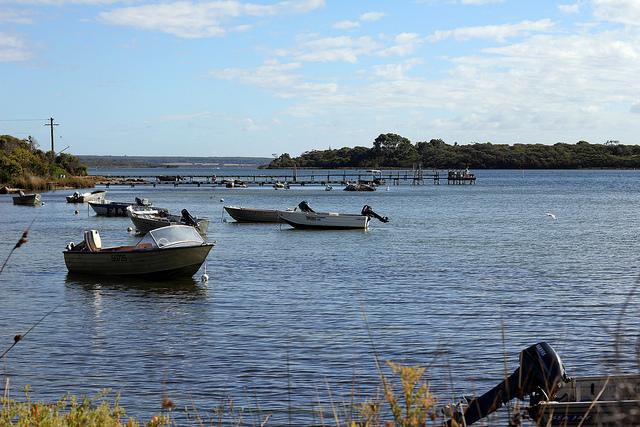Is this a vehicle?
Quick response, please. Yes. Is the water calm?
Short answer required. Yes. What season is it?
Answer briefly. Summer. Are any of the boats moving?
Keep it brief. No. Do all the boats have motors attached?
Give a very brief answer. Yes. 